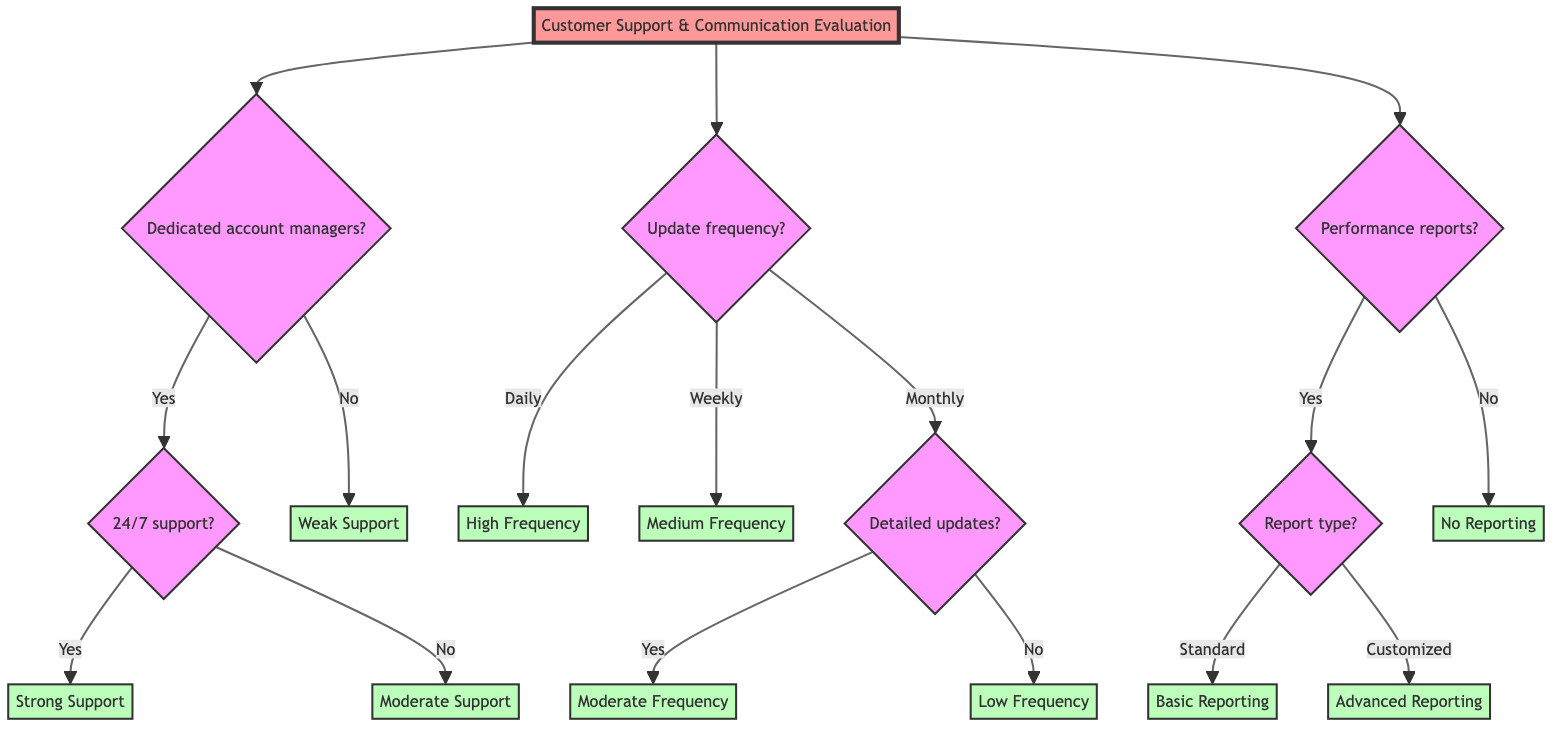What are the three main attributes considered in the evaluation? The diagram outlines three main attributes: Customer Support, Communication Frequency, and Reporting Practices. Each of these attributes serves as a category for evaluating digital marketing agencies based on specific criteria.
Answer: Customer Support, Communication Frequency, Reporting Practices What node follows after "Yes" for 24/7 support? After confirming that 24/7 support is available, the next node leads to "Strong Support," indicating a positive evaluation of the agency's customer support capabilities.
Answer: Strong Support How many outcomes are there for "Update frequency?" The "Update frequency" node has four possible outcomes: Daily, Weekly, Monthly (which branches further), leading to a total of four distinct outcomes.
Answer: Four What type of reporting is offered if the agency provides performance reports and the type is "Customized"? If the agency provides performance reports and they are categorized as "Customized," it results in "Advanced Reporting," indicating a higher level of detail and customization in the reports.
Answer: Advanced Reporting What will the evaluation be if an agency provides no performance reports? According to the diagram, if an agency provides no performance reports, the evaluation leads directly to the outcome "No Reporting," indicating a lack of accountability or transparency in performance metrics.
Answer: No Reporting Which node represents the weakest support level? The weakest support level is represented by the node "Weak Support," which occurs when the agency does not offer dedicated account managers.
Answer: Weak Support If an agency communicates weekly, what is the frequency rating? If an agency communicates on a weekly basis, it results in a "Medium Frequency" evaluation according to the diagram, which indicates a moderate level of communication with the client.
Answer: Medium Frequency What happens if an agency provides updates monthly but they are not detailed? If an agency provides monthly updates that are not detailed, the evaluation leads to the node "Low Frequency," suggesting insufficient communication.
Answer: Low Frequency 